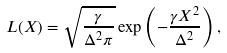<formula> <loc_0><loc_0><loc_500><loc_500>L ( X ) = \sqrt { \frac { \gamma } { \Delta ^ { 2 } \pi } } \exp \left ( { - \frac { \gamma X ^ { 2 } } { \Delta ^ { 2 } } } \right ) ,</formula> 